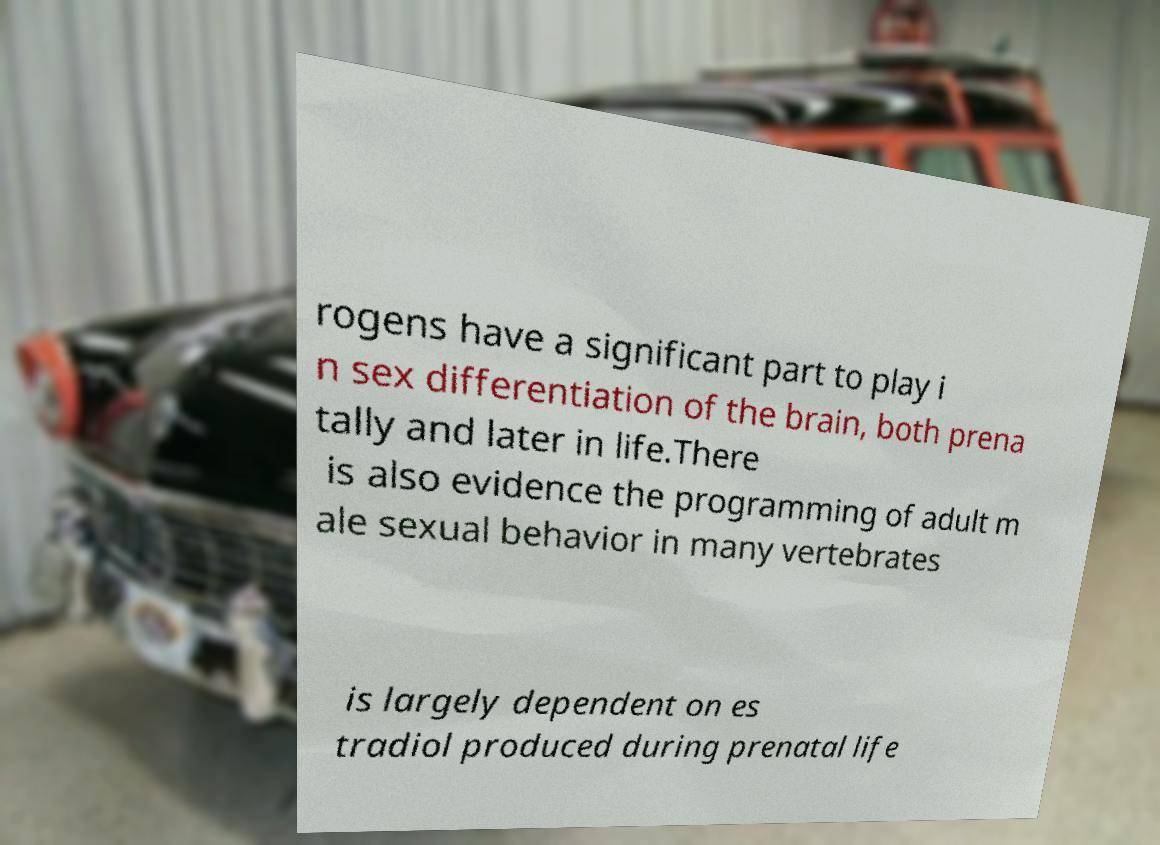For documentation purposes, I need the text within this image transcribed. Could you provide that? rogens have a significant part to play i n sex differentiation of the brain, both prena tally and later in life.There is also evidence the programming of adult m ale sexual behavior in many vertebrates is largely dependent on es tradiol produced during prenatal life 